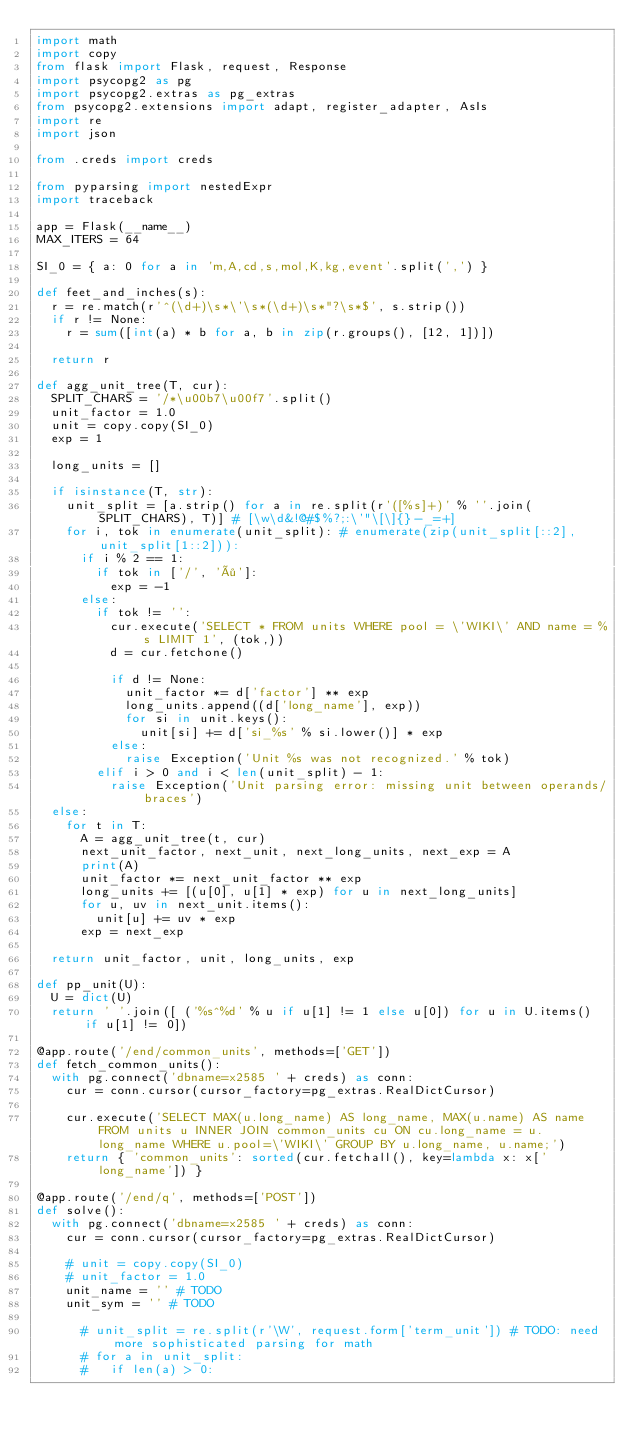<code> <loc_0><loc_0><loc_500><loc_500><_Python_>import math
import copy
from flask import Flask, request, Response
import psycopg2 as pg
import psycopg2.extras as pg_extras
from psycopg2.extensions import adapt, register_adapter, AsIs
import re
import json

from .creds import creds

from pyparsing import nestedExpr
import traceback

app = Flask(__name__)
MAX_ITERS = 64

SI_0 = { a: 0 for a in 'm,A,cd,s,mol,K,kg,event'.split(',') }

def feet_and_inches(s):
  r = re.match(r'^(\d+)\s*\'\s*(\d+)\s*"?\s*$', s.strip())
  if r != None:
    r = sum([int(a) * b for a, b in zip(r.groups(), [12, 1])])
    
  return r
  
def agg_unit_tree(T, cur):
  SPLIT_CHARS = '/*\u00b7\u00f7'.split()
  unit_factor = 1.0
  unit = copy.copy(SI_0)
  exp = 1
  
  long_units = []
  
  if isinstance(T, str):
    unit_split = [a.strip() for a in re.split(r'([%s]+)' % ''.join(SPLIT_CHARS), T)] # [\w\d&!@#$%?;:\'"\[\]{}-_=+]
    for i, tok in enumerate(unit_split): # enumerate(zip(unit_split[::2], unit_split[1::2])):
      if i % 2 == 1:
        if tok in ['/', '÷']:
          exp = -1
      else:
        if tok != '':
          cur.execute('SELECT * FROM units WHERE pool = \'WIKI\' AND name = %s LIMIT 1', (tok,))
          d = cur.fetchone()
            
          if d != None:
            unit_factor *= d['factor'] ** exp
            long_units.append((d['long_name'], exp))
            for si in unit.keys():
              unit[si] += d['si_%s' % si.lower()] * exp
          else:
            raise Exception('Unit %s was not recognized.' % tok)
        elif i > 0 and i < len(unit_split) - 1:
          raise Exception('Unit parsing error: missing unit between operands/braces')
  else:
    for t in T:
      A = agg_unit_tree(t, cur)
      next_unit_factor, next_unit, next_long_units, next_exp = A
      print(A)
      unit_factor *= next_unit_factor ** exp
      long_units += [(u[0], u[1] * exp) for u in next_long_units]
      for u, uv in next_unit.items():
        unit[u] += uv * exp
      exp = next_exp
      
  return unit_factor, unit, long_units, exp

def pp_unit(U):
  U = dict(U)
  return ' '.join([ ('%s^%d' % u if u[1] != 1 else u[0]) for u in U.items() if u[1] != 0])

@app.route('/end/common_units', methods=['GET'])
def fetch_common_units():
  with pg.connect('dbname=x2585 ' + creds) as conn:
    cur = conn.cursor(cursor_factory=pg_extras.RealDictCursor)
    
    cur.execute('SELECT MAX(u.long_name) AS long_name, MAX(u.name) AS name FROM units u INNER JOIN common_units cu ON cu.long_name = u.long_name WHERE u.pool=\'WIKI\' GROUP BY u.long_name, u.name;')
    return { 'common_units': sorted(cur.fetchall(), key=lambda x: x['long_name']) }

@app.route('/end/q', methods=['POST'])
def solve():
  with pg.connect('dbname=x2585 ' + creds) as conn:
    cur = conn.cursor(cursor_factory=pg_extras.RealDictCursor)
    
    # unit = copy.copy(SI_0)
    # unit_factor = 1.0
    unit_name = '' # TODO
    unit_sym = '' # TODO
      
      # unit_split = re.split(r'\W', request.form['term_unit']) # TODO: need more sophisticated parsing for math
      # for a in unit_split:
      #   if len(a) > 0:</code> 